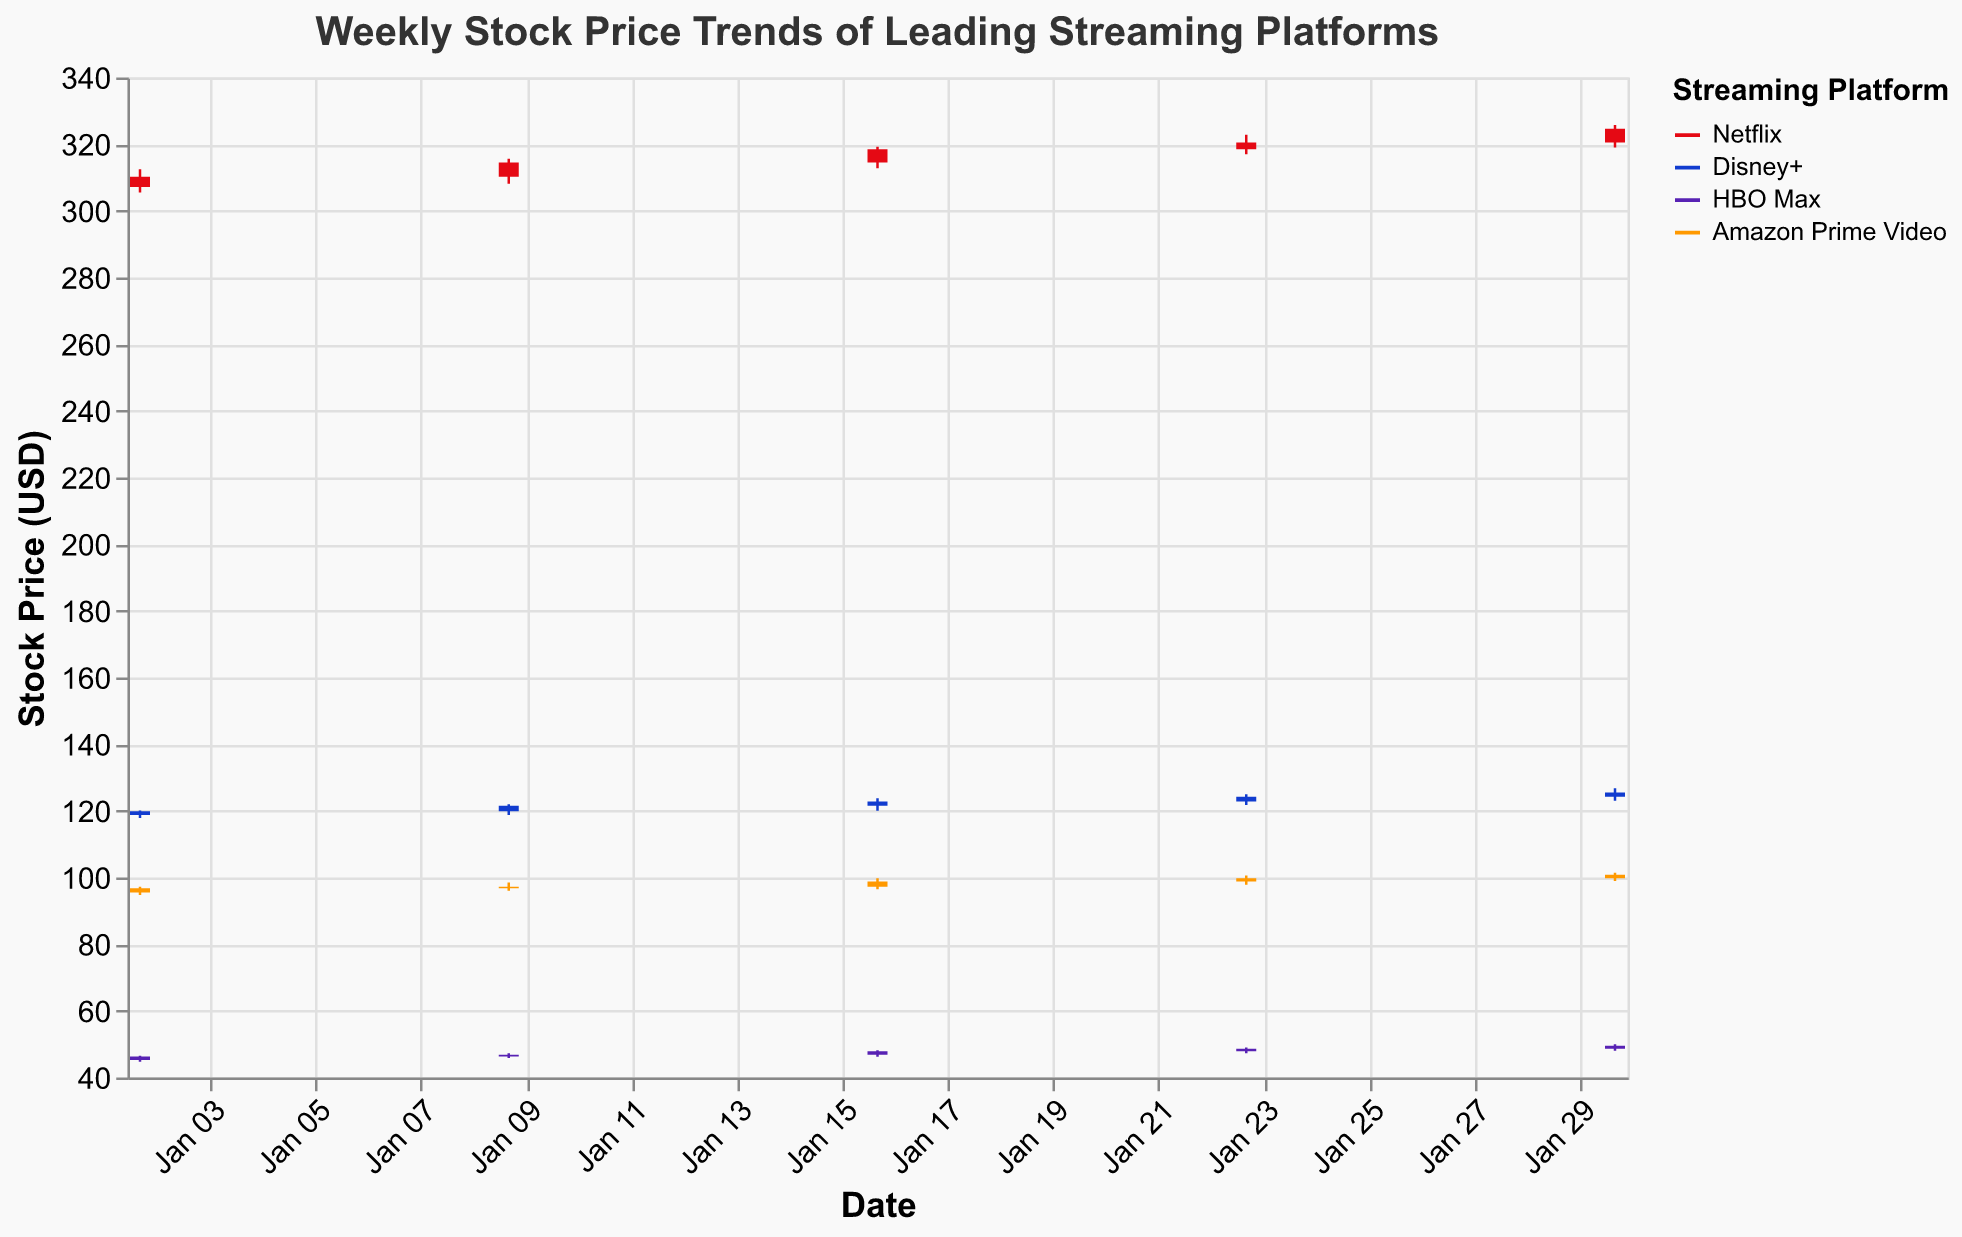Which streaming platform had the highest stock price on January 30, 2023? The stock prices on January 30, 2023, were: Netflix ($325.75), Disney+ ($126.75), HBO Max ($50.00), Amazon Prime Video ($101.45). Among these, Netflix had the highest stock price of $325.75
Answer: Netflix Did HBO Max experience a price increase or decrease from January 2 to January 9, 2023? On January 2, 2023, HBO Max's closing price was $46.30, and on January 9, 2023, it was $46.80. Since the price increased from $46.30 to $46.80, HBO Max experienced a price increase
Answer: increase What's the average closing price of Netflix in January 2023? The closing prices of Netflix in January 2023 are: $310.20, $314.50, $318.50, $320.50, and $324.60. To calculate the average, sum these values and divide by the number of data points: (310.20 + 314.50 + 318.50 + 320.50 + 324.60) / 5 = 317.26
Answer: 317.26 Which streaming platform had the most consistent (least volatile) stock price range (High - Low) over the month of January 2023? To determine consistency, calculate the range for each platform and evaluate the fluctuation:
Netflix ranges: (312.45 - 305.50), (315.60 - 308.15), (319.20 - 312.75), (322.85 - 317.00), (325.75 - 319.00)
Disney+ ranges: (120.12 - 117.85), (122.00 - 118.75), (123.75 - 120.00), (125.00 - 121.75), (126.75 - 123.00)
HBO Max ranges: (46.50 - 44.75), (47.25 - 45.85), (48.15 - 46.25), (49.00 - 47.25), (50.00 - 48.00)
Amazon ranges: (97.25 - 94.75), (98.50 - 96.00), (99.75 - 96.50), (100.60 - 97.85), (101.45 - 98.95)
Disney+ has the smallest range of fluctuations, indicating the most consistency
Answer: Disney+ On which date did Netflix have its highest closing price in January 2023? To find the highest closing price for Netflix, check each closing price in January: $310.20, $314.50, $318.50, $320.50, $324.60. The highest closing price is $324.60, which occurred on January 30, 2023
Answer: January 30, 2023 Between Amazon Prime Video and HBO Max, which platform had a higher volume of stocks traded on January 23, 2023? On January 23, 2023, Amazon Prime Video's volume was 9,800,000, while HBO Max's volume was 7,500,000. Therefore, Amazon Prime Video had the higher volume of stocks traded
Answer: Amazon Prime Video How many days did the closing price of Disney+ increase consecutively in January 2023? Checking Disney+ closing prices: Jan 2 ($119.90), Jan 9 ($121.50), Jan 16 ($122.80), Jan 23 ($124.20), and Jan 30 ($125.50). In each consecutive week, the closing price increased from the previous week. Therefore, Disney+'s closing price increased for 4 consecutive weeks
Answer: 4 What is the overall trend of Netflix's stock price during January 2023? Observing the closing prices of Netflix through January: $310.20, $314.50, $318.50, $320.50, $324.60. There is a consistent upward trend throughout the month
Answer: upward trend 